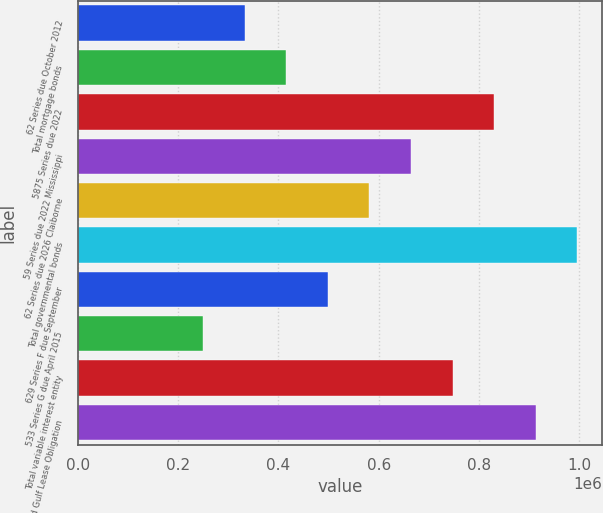<chart> <loc_0><loc_0><loc_500><loc_500><bar_chart><fcel>62 Series due October 2012<fcel>Total mortgage bonds<fcel>5875 Series due 2022<fcel>59 Series due 2022 Mississippi<fcel>62 Series due 2026 Claiborne<fcel>Total governmental bonds<fcel>629 Series F due September<fcel>533 Series G due April 2015<fcel>Total variable interest entity<fcel>Grand Gulf Lease Obligation<nl><fcel>332188<fcel>415235<fcel>830468<fcel>664375<fcel>581328<fcel>996561<fcel>498282<fcel>249142<fcel>747421<fcel>913515<nl></chart> 